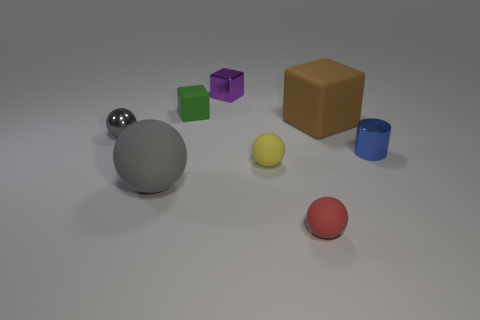Subtract 1 spheres. How many spheres are left? 3 Add 2 yellow matte cylinders. How many objects exist? 10 Subtract all cylinders. How many objects are left? 7 Subtract all large blocks. Subtract all tiny blue objects. How many objects are left? 6 Add 8 small blue metal cylinders. How many small blue metal cylinders are left? 9 Add 8 small brown metal cylinders. How many small brown metal cylinders exist? 8 Subtract 0 brown cylinders. How many objects are left? 8 